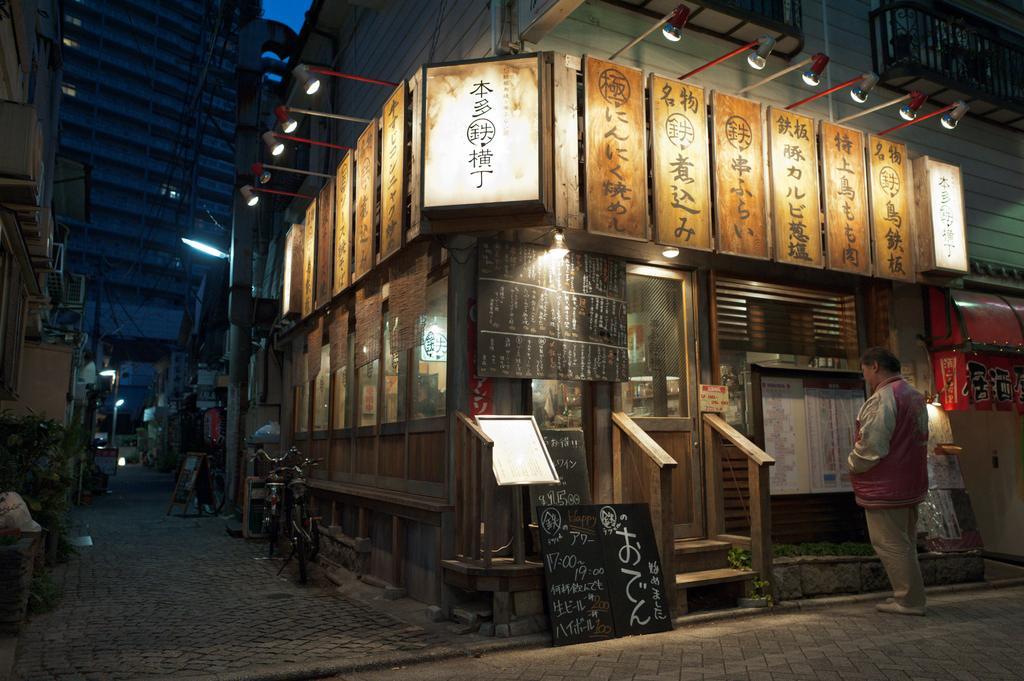How would you summarize this image in a sentence or two? In this image, on the right side, we can see a man standing in front of the board. On the board, we can see some charts attached to it. On the right side, we can also see a staircase and a glass door, we can also see a black color board with some text is written on it. On the left side, we can see a dustbin, plants, air conditioner and few lights. In the middle of the image, we can see some bicycles, boards. In the background, we can see a building, boards, glass window. At the top, we can see a roof with few lights, at the bottom, we can see a land. 